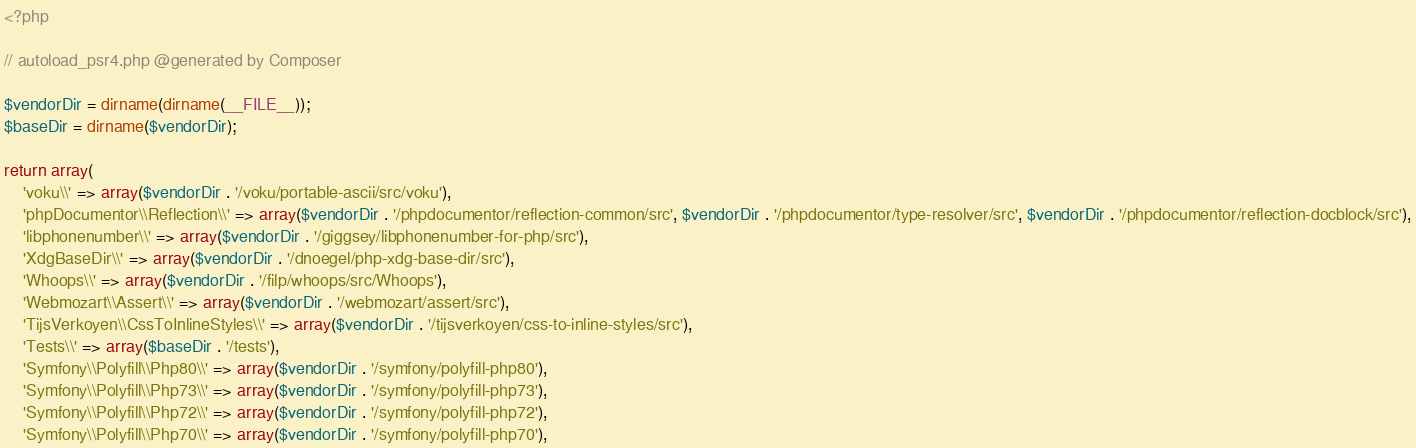<code> <loc_0><loc_0><loc_500><loc_500><_PHP_><?php

// autoload_psr4.php @generated by Composer

$vendorDir = dirname(dirname(__FILE__));
$baseDir = dirname($vendorDir);

return array(
    'voku\\' => array($vendorDir . '/voku/portable-ascii/src/voku'),
    'phpDocumentor\\Reflection\\' => array($vendorDir . '/phpdocumentor/reflection-common/src', $vendorDir . '/phpdocumentor/type-resolver/src', $vendorDir . '/phpdocumentor/reflection-docblock/src'),
    'libphonenumber\\' => array($vendorDir . '/giggsey/libphonenumber-for-php/src'),
    'XdgBaseDir\\' => array($vendorDir . '/dnoegel/php-xdg-base-dir/src'),
    'Whoops\\' => array($vendorDir . '/filp/whoops/src/Whoops'),
    'Webmozart\\Assert\\' => array($vendorDir . '/webmozart/assert/src'),
    'TijsVerkoyen\\CssToInlineStyles\\' => array($vendorDir . '/tijsverkoyen/css-to-inline-styles/src'),
    'Tests\\' => array($baseDir . '/tests'),
    'Symfony\\Polyfill\\Php80\\' => array($vendorDir . '/symfony/polyfill-php80'),
    'Symfony\\Polyfill\\Php73\\' => array($vendorDir . '/symfony/polyfill-php73'),
    'Symfony\\Polyfill\\Php72\\' => array($vendorDir . '/symfony/polyfill-php72'),
    'Symfony\\Polyfill\\Php70\\' => array($vendorDir . '/symfony/polyfill-php70'),</code> 